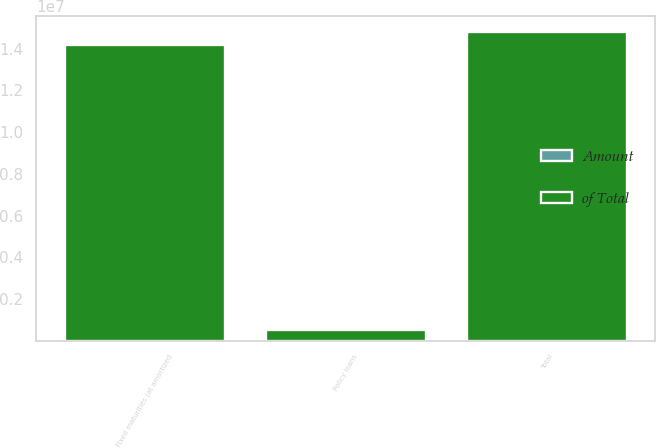<chart> <loc_0><loc_0><loc_500><loc_500><stacked_bar_chart><ecel><fcel>Fixed maturities (at amortized<fcel>Policy loans<fcel>Total<nl><fcel>of Total<fcel>1.4188e+07<fcel>507975<fcel>1.48214e+07<nl><fcel>Amount<fcel>96<fcel>3<fcel>100<nl></chart> 